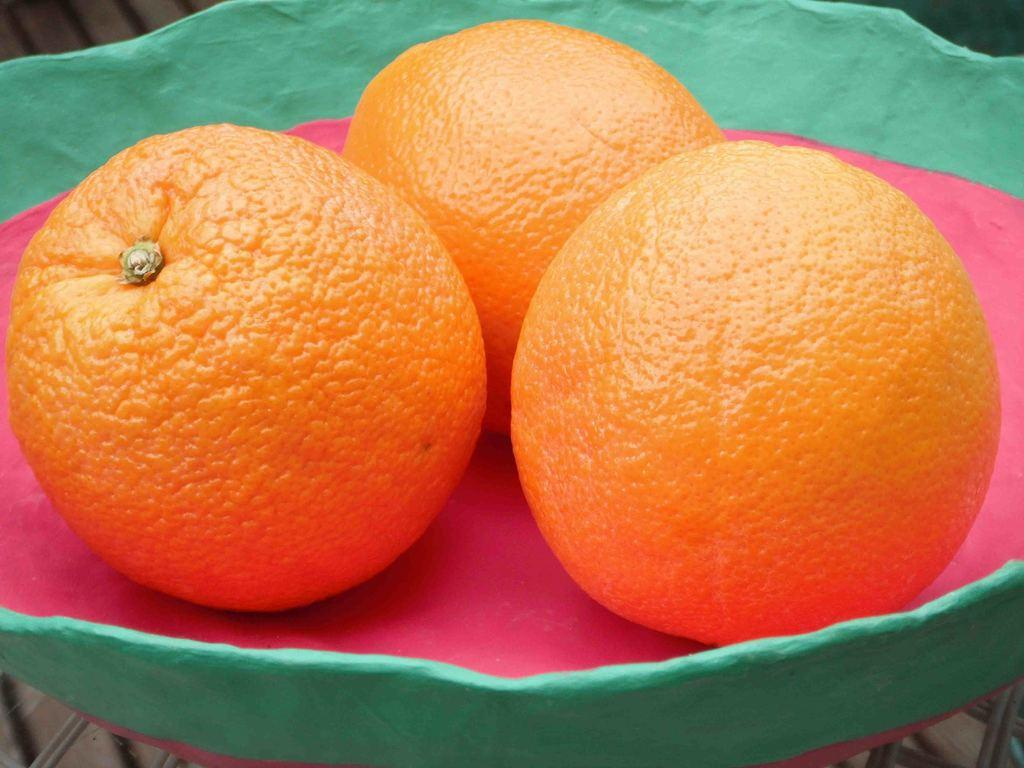How many oranges are visible in the image? There are three oranges in the image. Where are the oranges located in the image? The oranges are placed in a bowl. What type of sofa can be seen in the image? There is no sofa present in the image; it features three oranges placed in a bowl. How many toes are visible in the image? There are no toes visible in the image; it features three oranges placed in a bowl. 